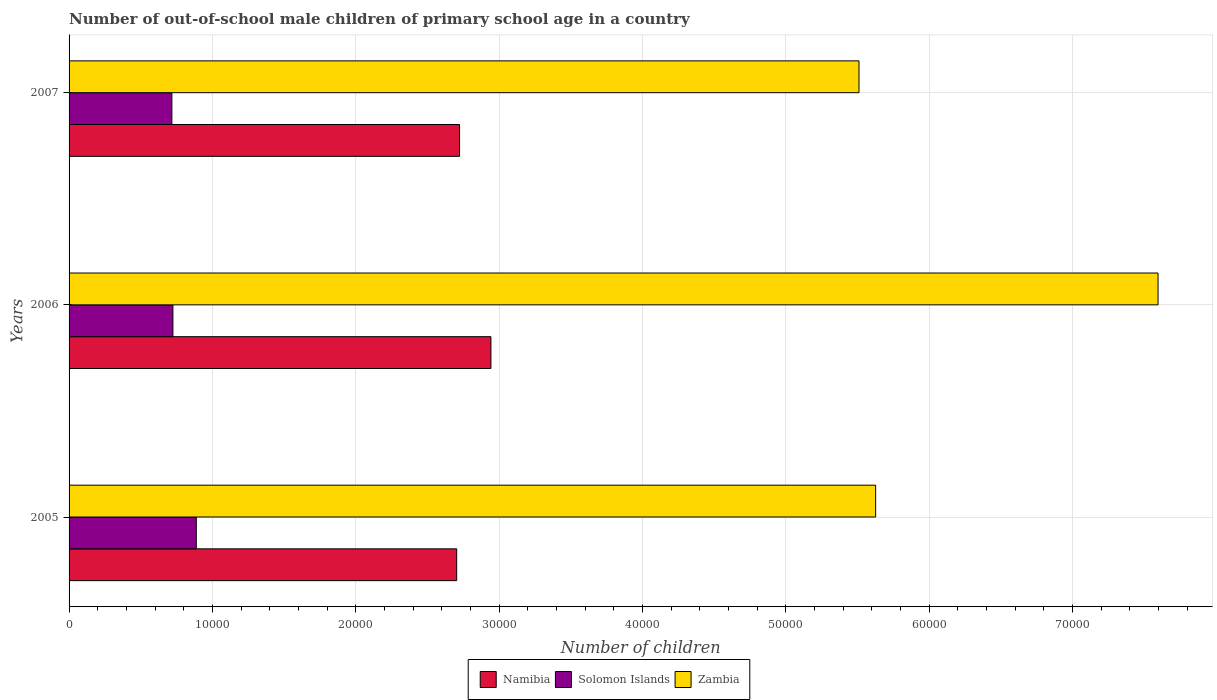How many different coloured bars are there?
Your answer should be very brief. 3. Are the number of bars per tick equal to the number of legend labels?
Give a very brief answer. Yes. How many bars are there on the 2nd tick from the top?
Give a very brief answer. 3. What is the label of the 1st group of bars from the top?
Offer a very short reply. 2007. In how many cases, is the number of bars for a given year not equal to the number of legend labels?
Give a very brief answer. 0. What is the number of out-of-school male children in Zambia in 2006?
Give a very brief answer. 7.60e+04. Across all years, what is the maximum number of out-of-school male children in Namibia?
Give a very brief answer. 2.94e+04. Across all years, what is the minimum number of out-of-school male children in Zambia?
Keep it short and to the point. 5.51e+04. What is the total number of out-of-school male children in Zambia in the graph?
Your answer should be very brief. 1.87e+05. What is the difference between the number of out-of-school male children in Namibia in 2005 and that in 2006?
Ensure brevity in your answer.  -2388. What is the difference between the number of out-of-school male children in Namibia in 2006 and the number of out-of-school male children in Solomon Islands in 2007?
Provide a succinct answer. 2.23e+04. What is the average number of out-of-school male children in Namibia per year?
Provide a short and direct response. 2.79e+04. In the year 2006, what is the difference between the number of out-of-school male children in Zambia and number of out-of-school male children in Solomon Islands?
Ensure brevity in your answer.  6.87e+04. In how many years, is the number of out-of-school male children in Namibia greater than 36000 ?
Your response must be concise. 0. What is the ratio of the number of out-of-school male children in Namibia in 2006 to that in 2007?
Your response must be concise. 1.08. Is the number of out-of-school male children in Solomon Islands in 2005 less than that in 2006?
Ensure brevity in your answer.  No. What is the difference between the highest and the second highest number of out-of-school male children in Solomon Islands?
Make the answer very short. 1630. What is the difference between the highest and the lowest number of out-of-school male children in Solomon Islands?
Your answer should be very brief. 1702. Is the sum of the number of out-of-school male children in Solomon Islands in 2006 and 2007 greater than the maximum number of out-of-school male children in Zambia across all years?
Make the answer very short. No. What does the 2nd bar from the top in 2007 represents?
Ensure brevity in your answer.  Solomon Islands. What does the 3rd bar from the bottom in 2006 represents?
Your response must be concise. Zambia. How many bars are there?
Your answer should be very brief. 9. How many years are there in the graph?
Your response must be concise. 3. Are the values on the major ticks of X-axis written in scientific E-notation?
Provide a short and direct response. No. How are the legend labels stacked?
Make the answer very short. Horizontal. What is the title of the graph?
Keep it short and to the point. Number of out-of-school male children of primary school age in a country. What is the label or title of the X-axis?
Ensure brevity in your answer.  Number of children. What is the Number of children of Namibia in 2005?
Your response must be concise. 2.70e+04. What is the Number of children in Solomon Islands in 2005?
Provide a short and direct response. 8874. What is the Number of children of Zambia in 2005?
Offer a terse response. 5.63e+04. What is the Number of children of Namibia in 2006?
Your answer should be compact. 2.94e+04. What is the Number of children in Solomon Islands in 2006?
Make the answer very short. 7244. What is the Number of children in Zambia in 2006?
Provide a short and direct response. 7.60e+04. What is the Number of children of Namibia in 2007?
Ensure brevity in your answer.  2.72e+04. What is the Number of children of Solomon Islands in 2007?
Your answer should be compact. 7172. What is the Number of children in Zambia in 2007?
Your answer should be very brief. 5.51e+04. Across all years, what is the maximum Number of children of Namibia?
Make the answer very short. 2.94e+04. Across all years, what is the maximum Number of children of Solomon Islands?
Keep it short and to the point. 8874. Across all years, what is the maximum Number of children of Zambia?
Your answer should be very brief. 7.60e+04. Across all years, what is the minimum Number of children of Namibia?
Offer a very short reply. 2.70e+04. Across all years, what is the minimum Number of children of Solomon Islands?
Provide a short and direct response. 7172. Across all years, what is the minimum Number of children of Zambia?
Provide a short and direct response. 5.51e+04. What is the total Number of children in Namibia in the graph?
Give a very brief answer. 8.37e+04. What is the total Number of children in Solomon Islands in the graph?
Make the answer very short. 2.33e+04. What is the total Number of children in Zambia in the graph?
Your answer should be compact. 1.87e+05. What is the difference between the Number of children in Namibia in 2005 and that in 2006?
Your answer should be very brief. -2388. What is the difference between the Number of children of Solomon Islands in 2005 and that in 2006?
Give a very brief answer. 1630. What is the difference between the Number of children of Zambia in 2005 and that in 2006?
Provide a short and direct response. -1.97e+04. What is the difference between the Number of children in Namibia in 2005 and that in 2007?
Provide a succinct answer. -201. What is the difference between the Number of children of Solomon Islands in 2005 and that in 2007?
Provide a succinct answer. 1702. What is the difference between the Number of children in Zambia in 2005 and that in 2007?
Offer a very short reply. 1160. What is the difference between the Number of children of Namibia in 2006 and that in 2007?
Make the answer very short. 2187. What is the difference between the Number of children in Zambia in 2006 and that in 2007?
Your response must be concise. 2.09e+04. What is the difference between the Number of children in Namibia in 2005 and the Number of children in Solomon Islands in 2006?
Make the answer very short. 1.98e+04. What is the difference between the Number of children of Namibia in 2005 and the Number of children of Zambia in 2006?
Offer a terse response. -4.89e+04. What is the difference between the Number of children of Solomon Islands in 2005 and the Number of children of Zambia in 2006?
Give a very brief answer. -6.71e+04. What is the difference between the Number of children of Namibia in 2005 and the Number of children of Solomon Islands in 2007?
Ensure brevity in your answer.  1.99e+04. What is the difference between the Number of children in Namibia in 2005 and the Number of children in Zambia in 2007?
Offer a terse response. -2.81e+04. What is the difference between the Number of children in Solomon Islands in 2005 and the Number of children in Zambia in 2007?
Provide a short and direct response. -4.62e+04. What is the difference between the Number of children in Namibia in 2006 and the Number of children in Solomon Islands in 2007?
Provide a succinct answer. 2.23e+04. What is the difference between the Number of children in Namibia in 2006 and the Number of children in Zambia in 2007?
Make the answer very short. -2.57e+04. What is the difference between the Number of children in Solomon Islands in 2006 and the Number of children in Zambia in 2007?
Make the answer very short. -4.79e+04. What is the average Number of children in Namibia per year?
Provide a succinct answer. 2.79e+04. What is the average Number of children in Solomon Islands per year?
Your answer should be compact. 7763.33. What is the average Number of children in Zambia per year?
Your response must be concise. 6.24e+04. In the year 2005, what is the difference between the Number of children in Namibia and Number of children in Solomon Islands?
Your response must be concise. 1.82e+04. In the year 2005, what is the difference between the Number of children in Namibia and Number of children in Zambia?
Provide a succinct answer. -2.92e+04. In the year 2005, what is the difference between the Number of children in Solomon Islands and Number of children in Zambia?
Offer a terse response. -4.74e+04. In the year 2006, what is the difference between the Number of children of Namibia and Number of children of Solomon Islands?
Keep it short and to the point. 2.22e+04. In the year 2006, what is the difference between the Number of children in Namibia and Number of children in Zambia?
Give a very brief answer. -4.65e+04. In the year 2006, what is the difference between the Number of children of Solomon Islands and Number of children of Zambia?
Provide a succinct answer. -6.87e+04. In the year 2007, what is the difference between the Number of children of Namibia and Number of children of Solomon Islands?
Ensure brevity in your answer.  2.01e+04. In the year 2007, what is the difference between the Number of children of Namibia and Number of children of Zambia?
Give a very brief answer. -2.79e+04. In the year 2007, what is the difference between the Number of children in Solomon Islands and Number of children in Zambia?
Keep it short and to the point. -4.79e+04. What is the ratio of the Number of children of Namibia in 2005 to that in 2006?
Provide a succinct answer. 0.92. What is the ratio of the Number of children of Solomon Islands in 2005 to that in 2006?
Provide a short and direct response. 1.23. What is the ratio of the Number of children in Zambia in 2005 to that in 2006?
Offer a very short reply. 0.74. What is the ratio of the Number of children of Namibia in 2005 to that in 2007?
Make the answer very short. 0.99. What is the ratio of the Number of children of Solomon Islands in 2005 to that in 2007?
Keep it short and to the point. 1.24. What is the ratio of the Number of children in Zambia in 2005 to that in 2007?
Offer a very short reply. 1.02. What is the ratio of the Number of children in Namibia in 2006 to that in 2007?
Your answer should be very brief. 1.08. What is the ratio of the Number of children in Zambia in 2006 to that in 2007?
Give a very brief answer. 1.38. What is the difference between the highest and the second highest Number of children in Namibia?
Provide a succinct answer. 2187. What is the difference between the highest and the second highest Number of children of Solomon Islands?
Your answer should be very brief. 1630. What is the difference between the highest and the second highest Number of children in Zambia?
Your answer should be compact. 1.97e+04. What is the difference between the highest and the lowest Number of children of Namibia?
Your answer should be compact. 2388. What is the difference between the highest and the lowest Number of children in Solomon Islands?
Your answer should be very brief. 1702. What is the difference between the highest and the lowest Number of children of Zambia?
Your answer should be very brief. 2.09e+04. 